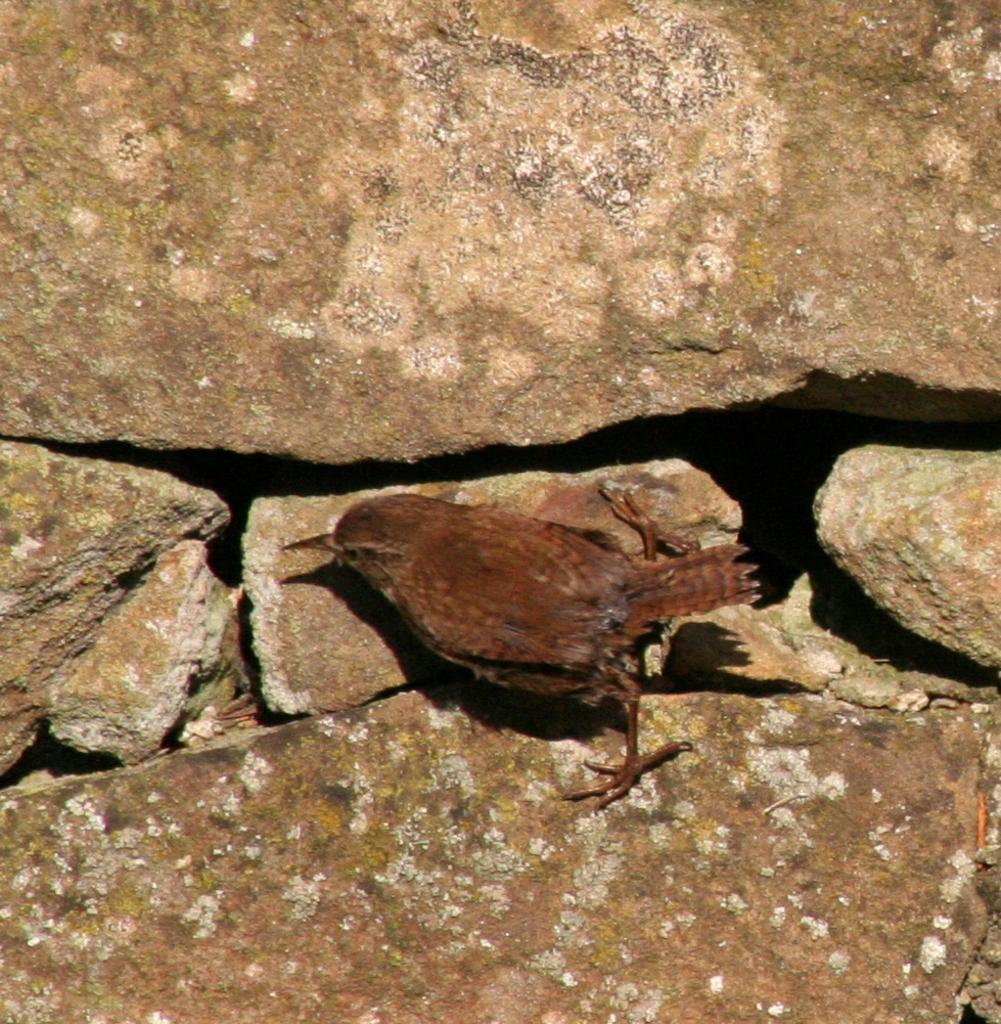What type of animal can be seen in the image? There is a bird in the image. Where is the bird located? The bird is on a rock. What type of playground equipment can be seen in the image? There is no playground equipment present in the image; it features a bird on a rock. Is there a kitty playing with the bird in the image? There is no kitty present in the image, and the bird is not engaged in any playful activity. 